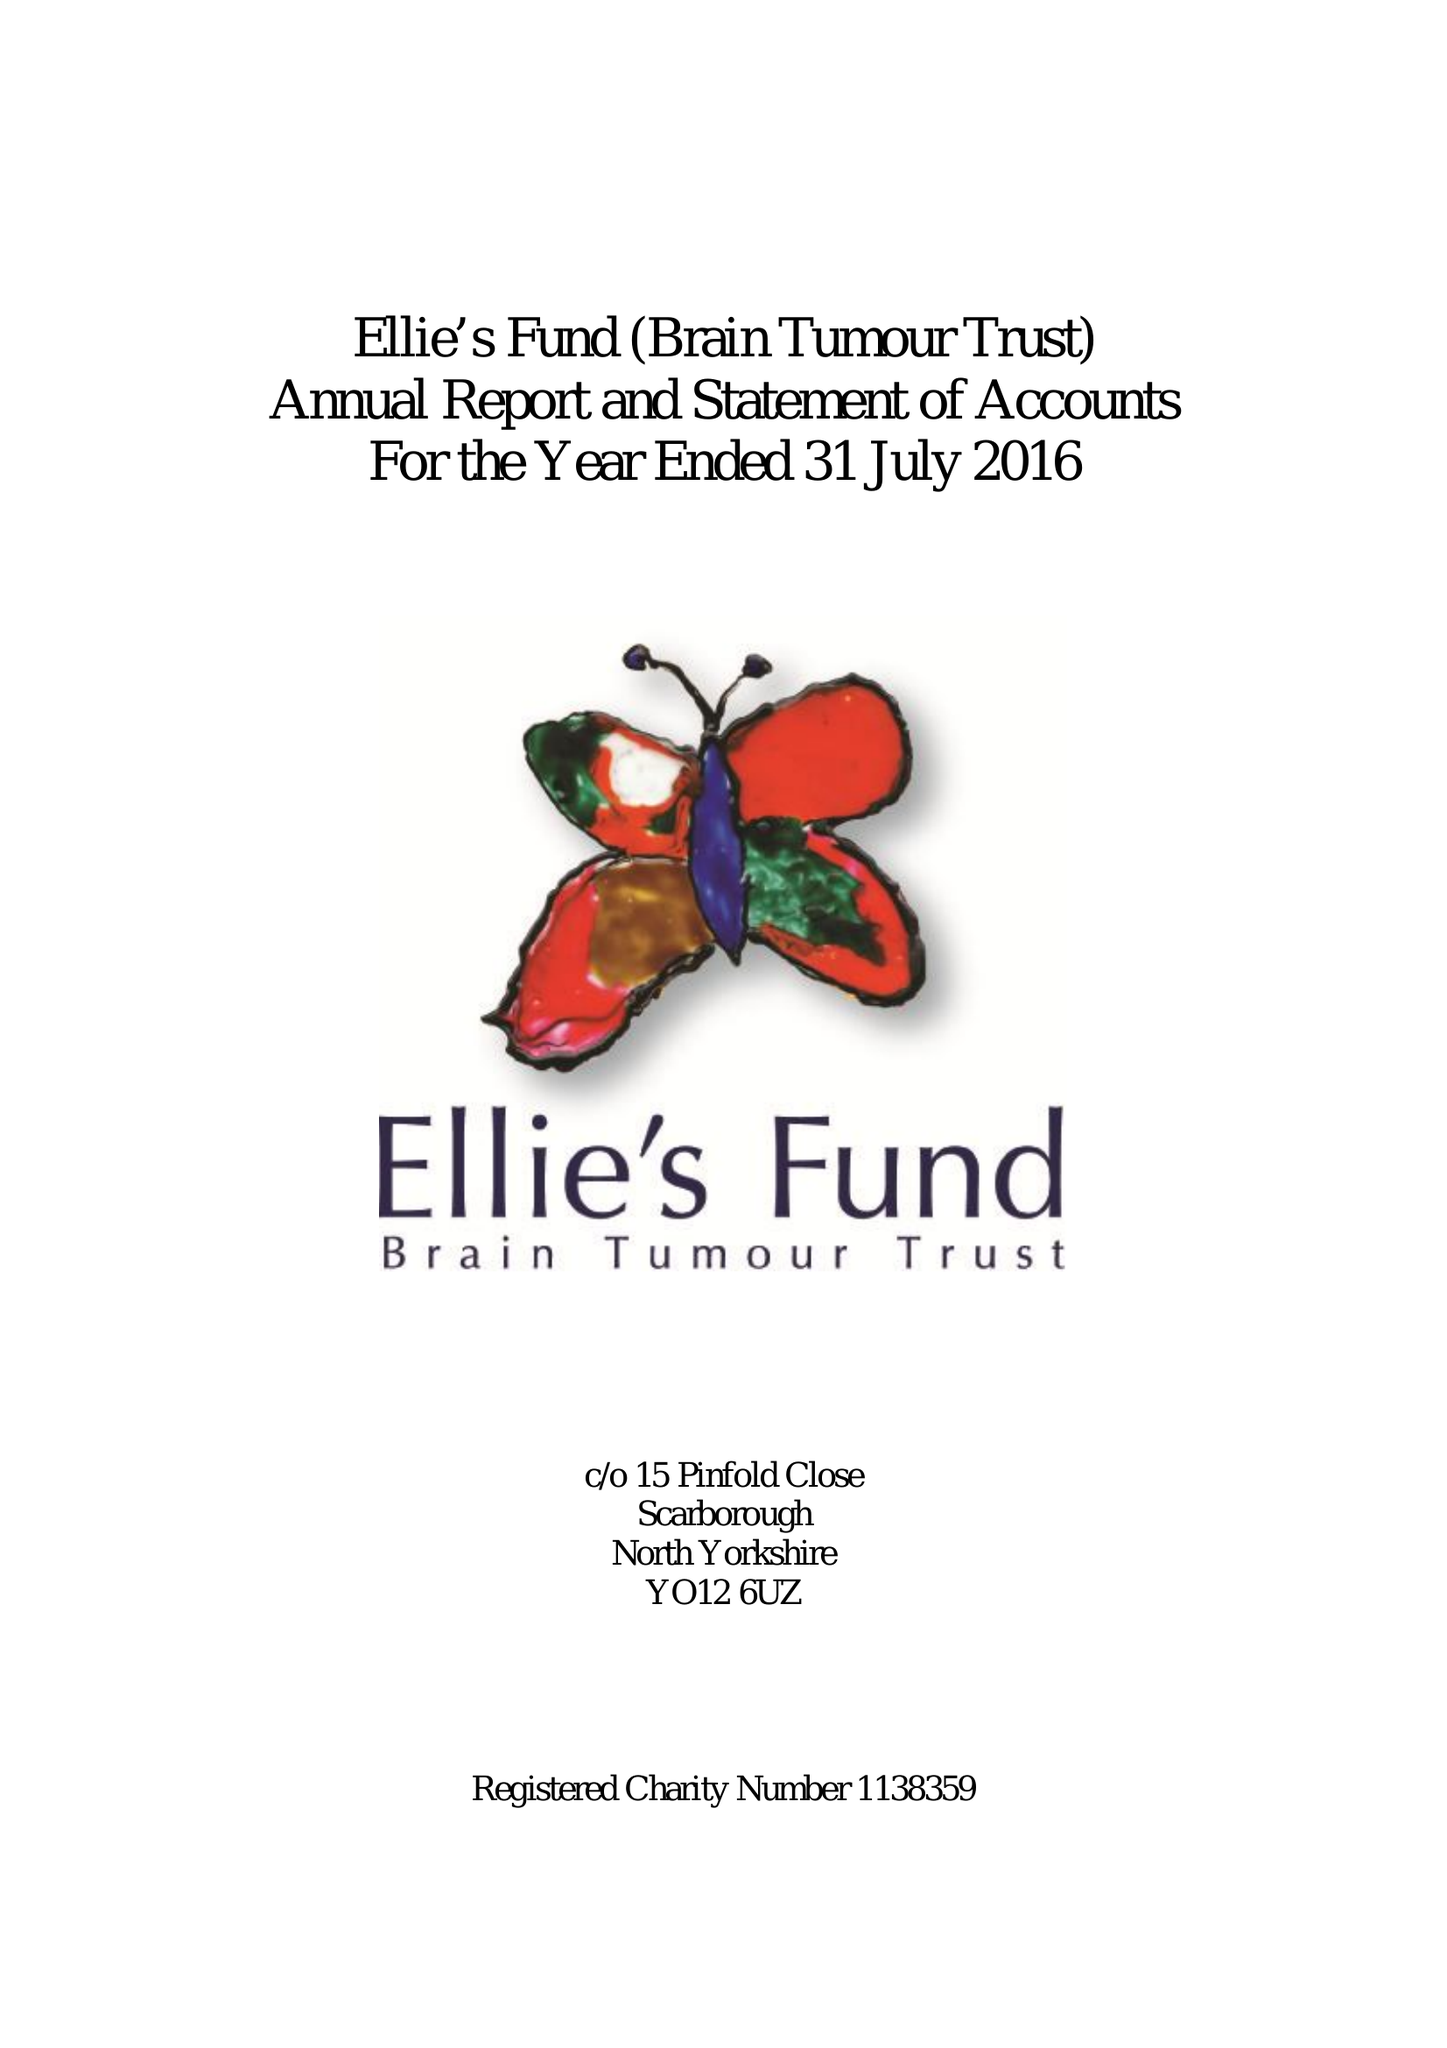What is the value for the address__post_town?
Answer the question using a single word or phrase. None 